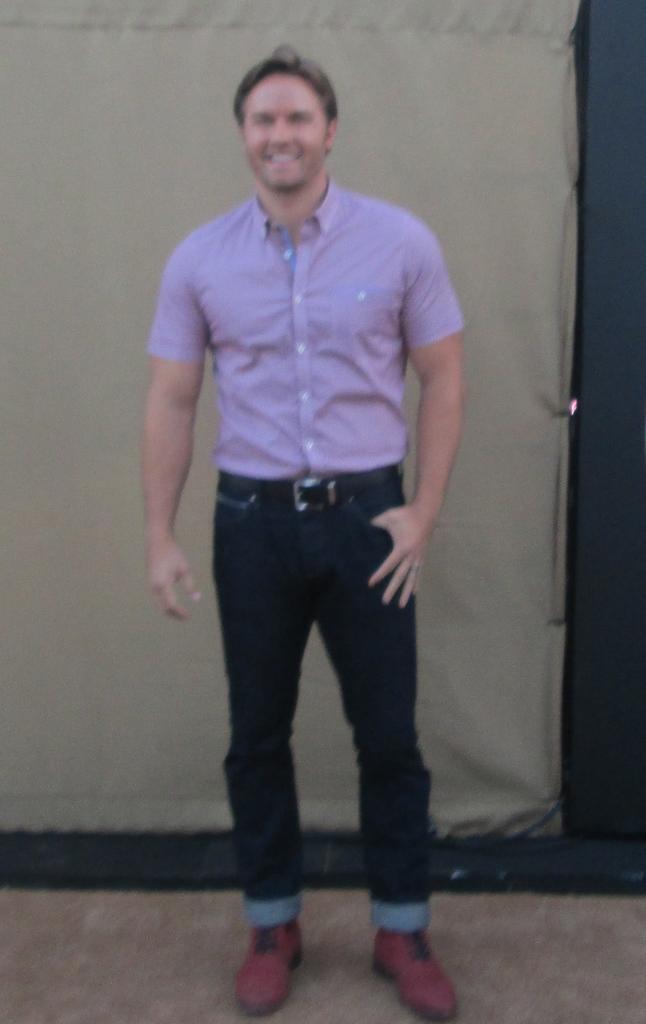In one or two sentences, can you explain what this image depicts? In this image we can see a man. In the back there is a wall. 